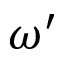<formula> <loc_0><loc_0><loc_500><loc_500>\omega ^ { \prime }</formula> 